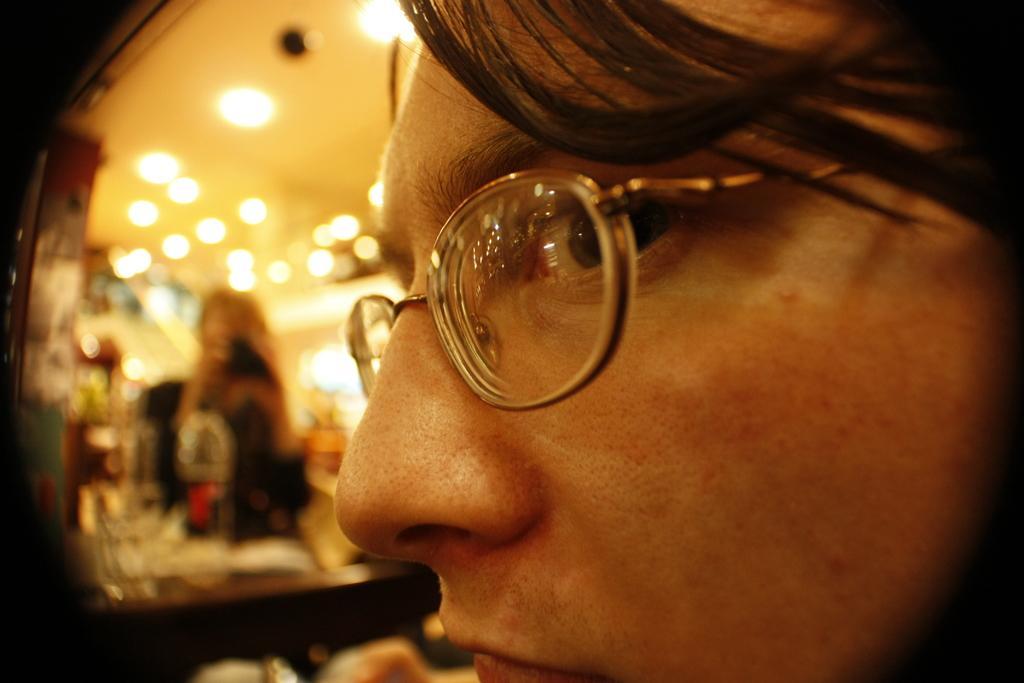Can you describe this image briefly? In this picture I can see a woman wearing spectacles and side I can see a mirror reflection on which I can see a woman holding camera. 